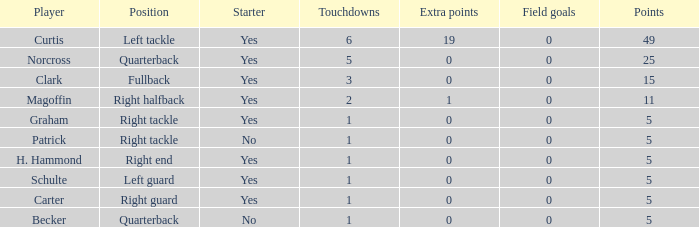Which field goals hold the top position in terms of numbers? 0.0. 